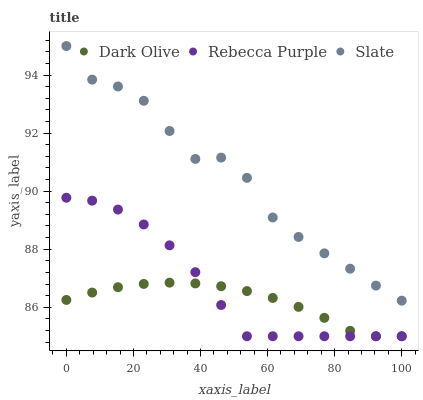Does Dark Olive have the minimum area under the curve?
Answer yes or no. Yes. Does Slate have the maximum area under the curve?
Answer yes or no. Yes. Does Rebecca Purple have the minimum area under the curve?
Answer yes or no. No. Does Rebecca Purple have the maximum area under the curve?
Answer yes or no. No. Is Dark Olive the smoothest?
Answer yes or no. Yes. Is Slate the roughest?
Answer yes or no. Yes. Is Rebecca Purple the smoothest?
Answer yes or no. No. Is Rebecca Purple the roughest?
Answer yes or no. No. Does Dark Olive have the lowest value?
Answer yes or no. Yes. Does Slate have the highest value?
Answer yes or no. Yes. Does Rebecca Purple have the highest value?
Answer yes or no. No. Is Rebecca Purple less than Slate?
Answer yes or no. Yes. Is Slate greater than Rebecca Purple?
Answer yes or no. Yes. Does Rebecca Purple intersect Dark Olive?
Answer yes or no. Yes. Is Rebecca Purple less than Dark Olive?
Answer yes or no. No. Is Rebecca Purple greater than Dark Olive?
Answer yes or no. No. Does Rebecca Purple intersect Slate?
Answer yes or no. No. 